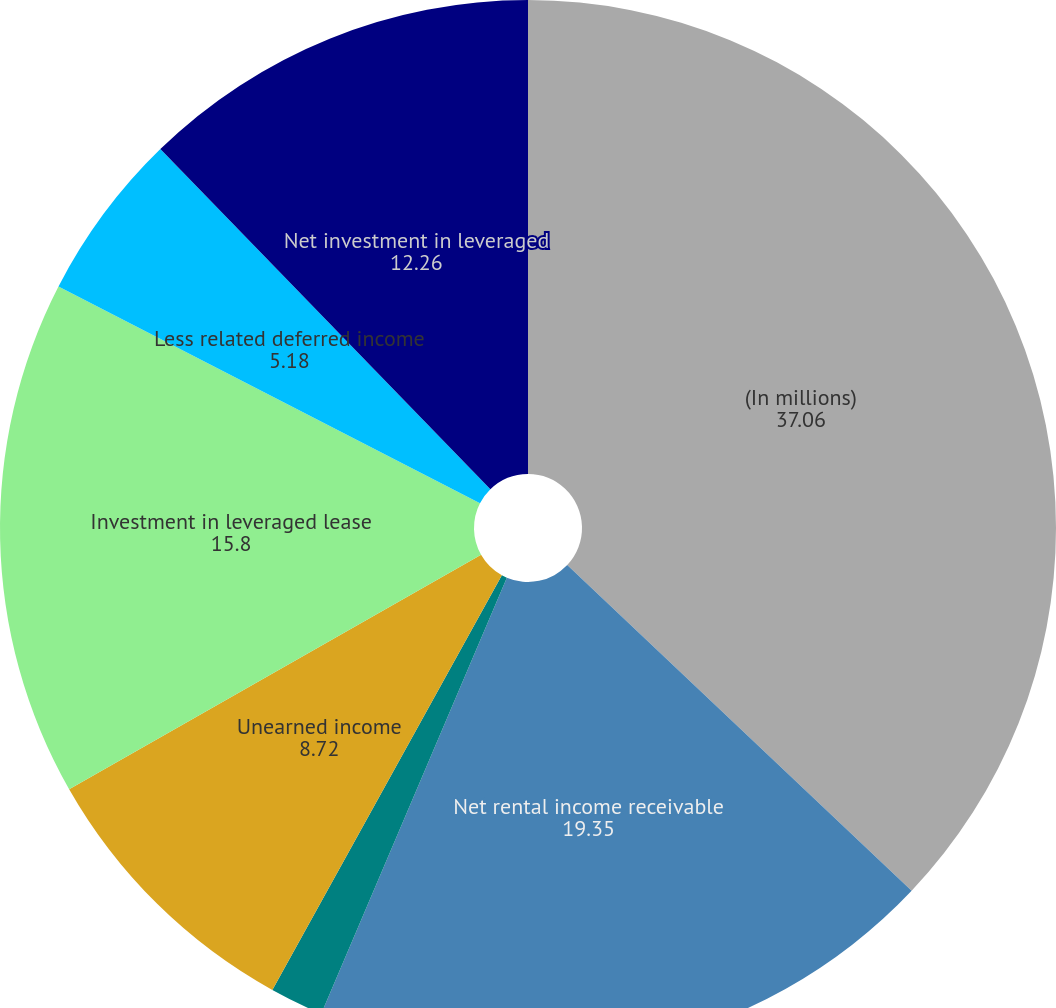Convert chart to OTSL. <chart><loc_0><loc_0><loc_500><loc_500><pie_chart><fcel>(In millions)<fcel>Net rental income receivable<fcel>Estimated residual values<fcel>Unearned income<fcel>Investment in leveraged lease<fcel>Less related deferred income<fcel>Net investment in leveraged<nl><fcel>37.06%<fcel>19.35%<fcel>1.64%<fcel>8.72%<fcel>15.8%<fcel>5.18%<fcel>12.26%<nl></chart> 